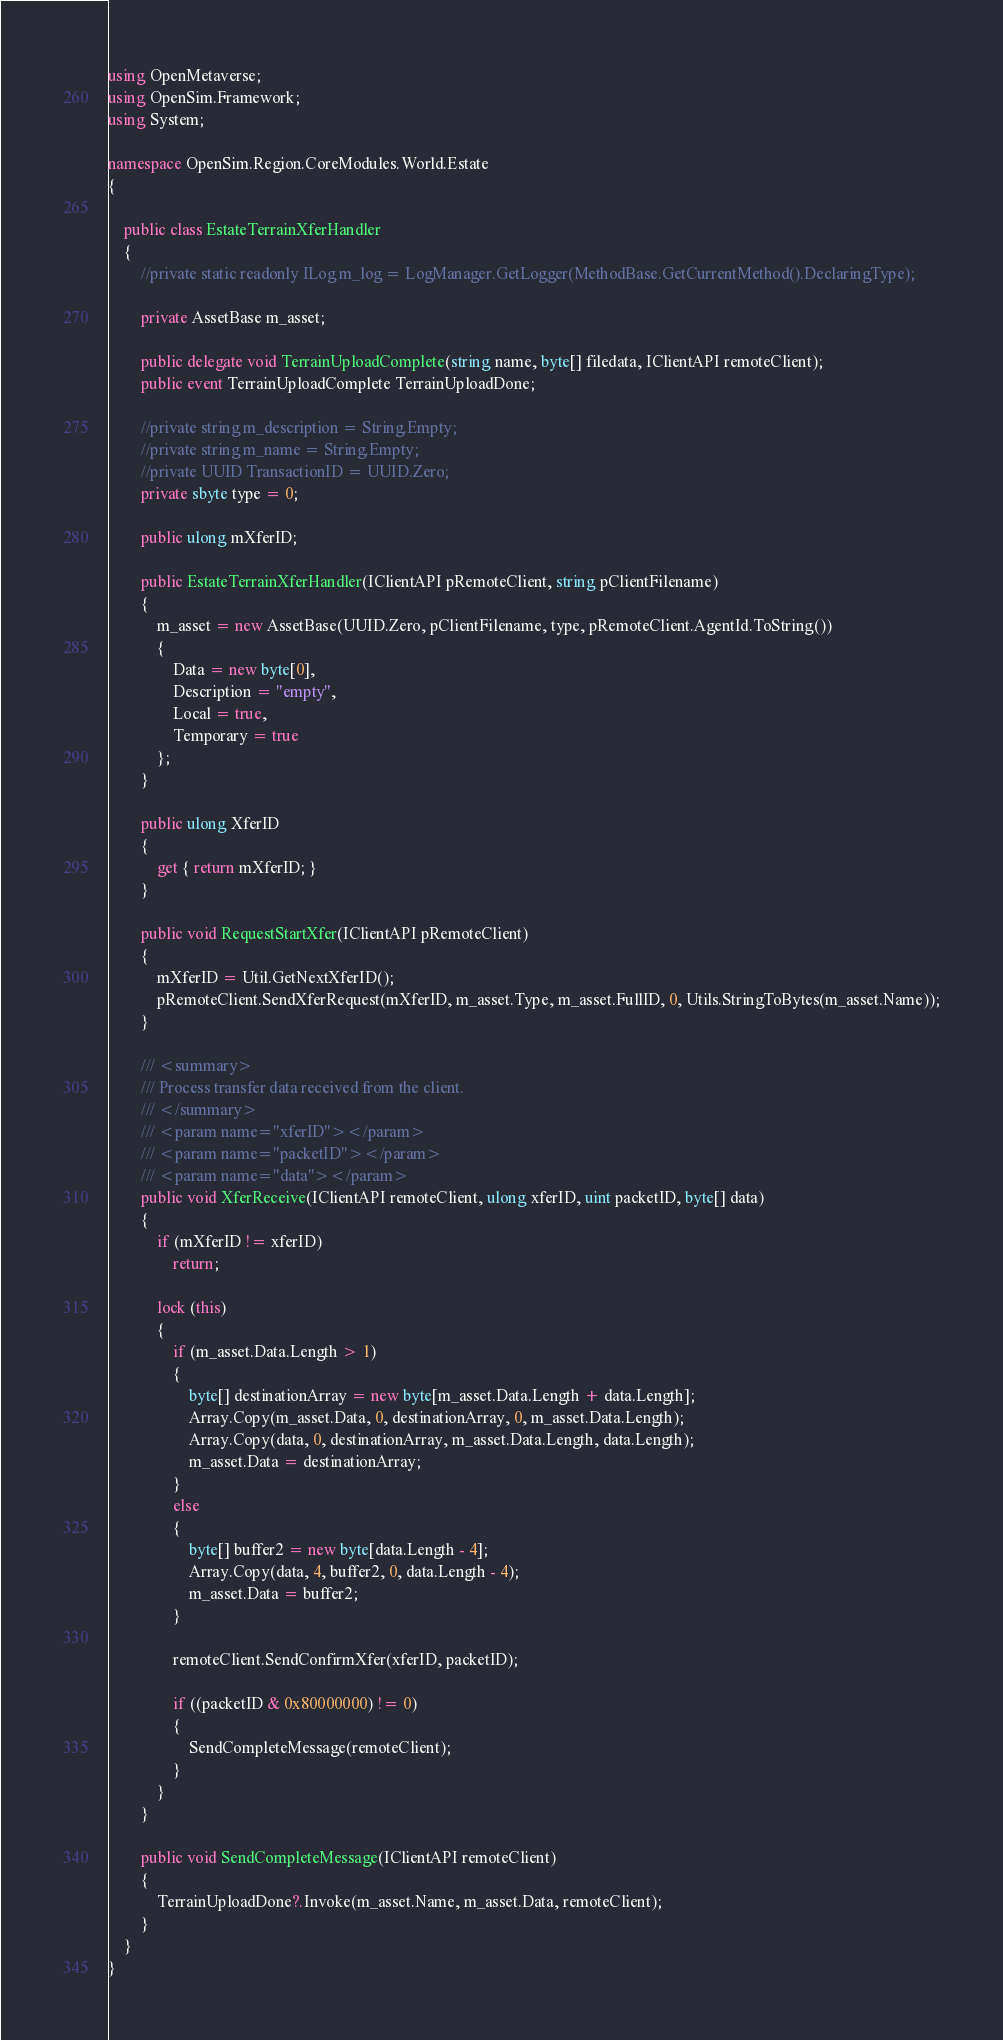Convert code to text. <code><loc_0><loc_0><loc_500><loc_500><_C#_>
using OpenMetaverse;
using OpenSim.Framework;
using System;

namespace OpenSim.Region.CoreModules.World.Estate
{

    public class EstateTerrainXferHandler
    {
        //private static readonly ILog m_log = LogManager.GetLogger(MethodBase.GetCurrentMethod().DeclaringType);

        private AssetBase m_asset;

        public delegate void TerrainUploadComplete(string name, byte[] filedata, IClientAPI remoteClient);
        public event TerrainUploadComplete TerrainUploadDone;

        //private string m_description = String.Empty;
        //private string m_name = String.Empty;
        //private UUID TransactionID = UUID.Zero;
        private sbyte type = 0;

        public ulong mXferID;

        public EstateTerrainXferHandler(IClientAPI pRemoteClient, string pClientFilename)
        {
            m_asset = new AssetBase(UUID.Zero, pClientFilename, type, pRemoteClient.AgentId.ToString())
            {
                Data = new byte[0],
                Description = "empty",
                Local = true,
                Temporary = true
            };
        }

        public ulong XferID
        {
            get { return mXferID; }
        }

        public void RequestStartXfer(IClientAPI pRemoteClient)
        {
            mXferID = Util.GetNextXferID();
            pRemoteClient.SendXferRequest(mXferID, m_asset.Type, m_asset.FullID, 0, Utils.StringToBytes(m_asset.Name));
        }

        /// <summary>
        /// Process transfer data received from the client.
        /// </summary>
        /// <param name="xferID"></param>
        /// <param name="packetID"></param>
        /// <param name="data"></param>
        public void XferReceive(IClientAPI remoteClient, ulong xferID, uint packetID, byte[] data)
        {
            if (mXferID != xferID)
                return;

            lock (this)
            {
                if (m_asset.Data.Length > 1)
                {
                    byte[] destinationArray = new byte[m_asset.Data.Length + data.Length];
                    Array.Copy(m_asset.Data, 0, destinationArray, 0, m_asset.Data.Length);
                    Array.Copy(data, 0, destinationArray, m_asset.Data.Length, data.Length);
                    m_asset.Data = destinationArray;
                }
                else
                {
                    byte[] buffer2 = new byte[data.Length - 4];
                    Array.Copy(data, 4, buffer2, 0, data.Length - 4);
                    m_asset.Data = buffer2;
                }

                remoteClient.SendConfirmXfer(xferID, packetID);

                if ((packetID & 0x80000000) != 0)
                {
                    SendCompleteMessage(remoteClient);
                }
            }
        }

        public void SendCompleteMessage(IClientAPI remoteClient)
        {
            TerrainUploadDone?.Invoke(m_asset.Name, m_asset.Data, remoteClient);
        }
    }
}
</code> 